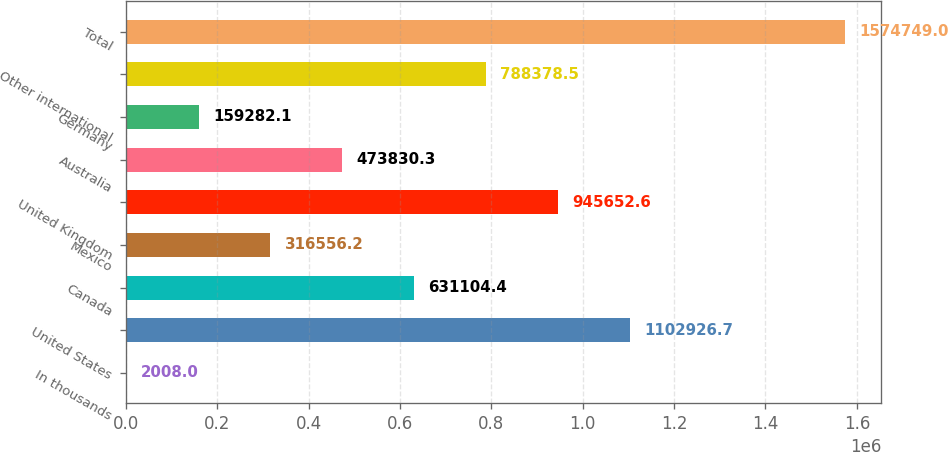Convert chart. <chart><loc_0><loc_0><loc_500><loc_500><bar_chart><fcel>In thousands<fcel>United States<fcel>Canada<fcel>Mexico<fcel>United Kingdom<fcel>Australia<fcel>Germany<fcel>Other international<fcel>Total<nl><fcel>2008<fcel>1.10293e+06<fcel>631104<fcel>316556<fcel>945653<fcel>473830<fcel>159282<fcel>788378<fcel>1.57475e+06<nl></chart> 